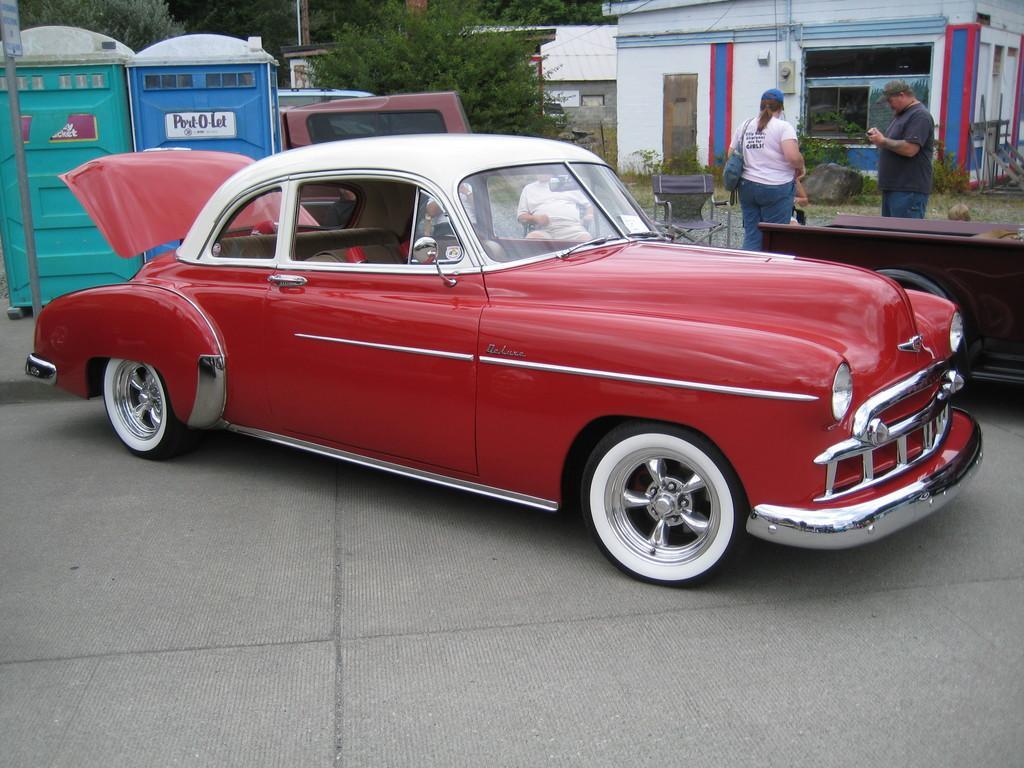How would you summarize this image in a sentence or two? This is an outside view. Here I can see a red color car on the road. On the left side there are two boxes which are placed on the road and on the right side, I can see two people are standing and also there is a chair and a table. In the background, I can see a building and trees. 